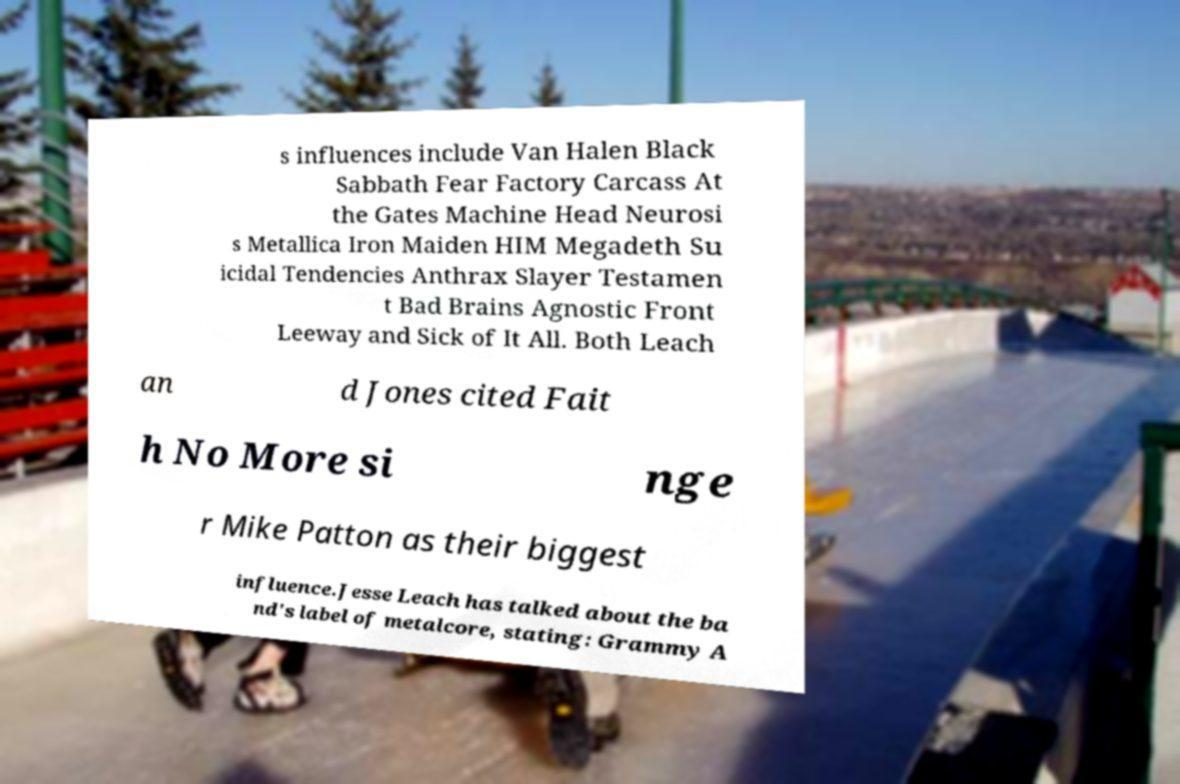What messages or text are displayed in this image? I need them in a readable, typed format. s influences include Van Halen Black Sabbath Fear Factory Carcass At the Gates Machine Head Neurosi s Metallica Iron Maiden HIM Megadeth Su icidal Tendencies Anthrax Slayer Testamen t Bad Brains Agnostic Front Leeway and Sick of It All. Both Leach an d Jones cited Fait h No More si nge r Mike Patton as their biggest influence.Jesse Leach has talked about the ba nd's label of metalcore, stating: Grammy A 